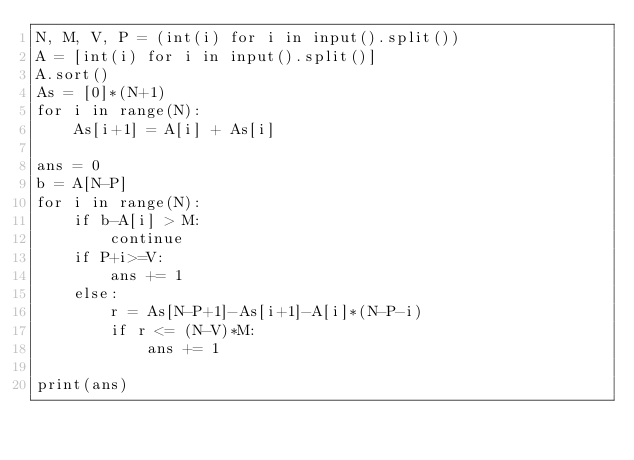Convert code to text. <code><loc_0><loc_0><loc_500><loc_500><_Python_>N, M, V, P = (int(i) for i in input().split())
A = [int(i) for i in input().split()]
A.sort()
As = [0]*(N+1)
for i in range(N):
    As[i+1] = A[i] + As[i]

ans = 0
b = A[N-P]
for i in range(N):
    if b-A[i] > M:
        continue
    if P+i>=V:
        ans += 1
    else:
        r = As[N-P+1]-As[i+1]-A[i]*(N-P-i)
        if r <= (N-V)*M:
            ans += 1

print(ans)</code> 